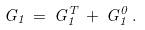<formula> <loc_0><loc_0><loc_500><loc_500>G _ { 1 } \, = \, G ^ { T } _ { 1 } \, + \, G ^ { 0 } _ { 1 } \, .</formula> 